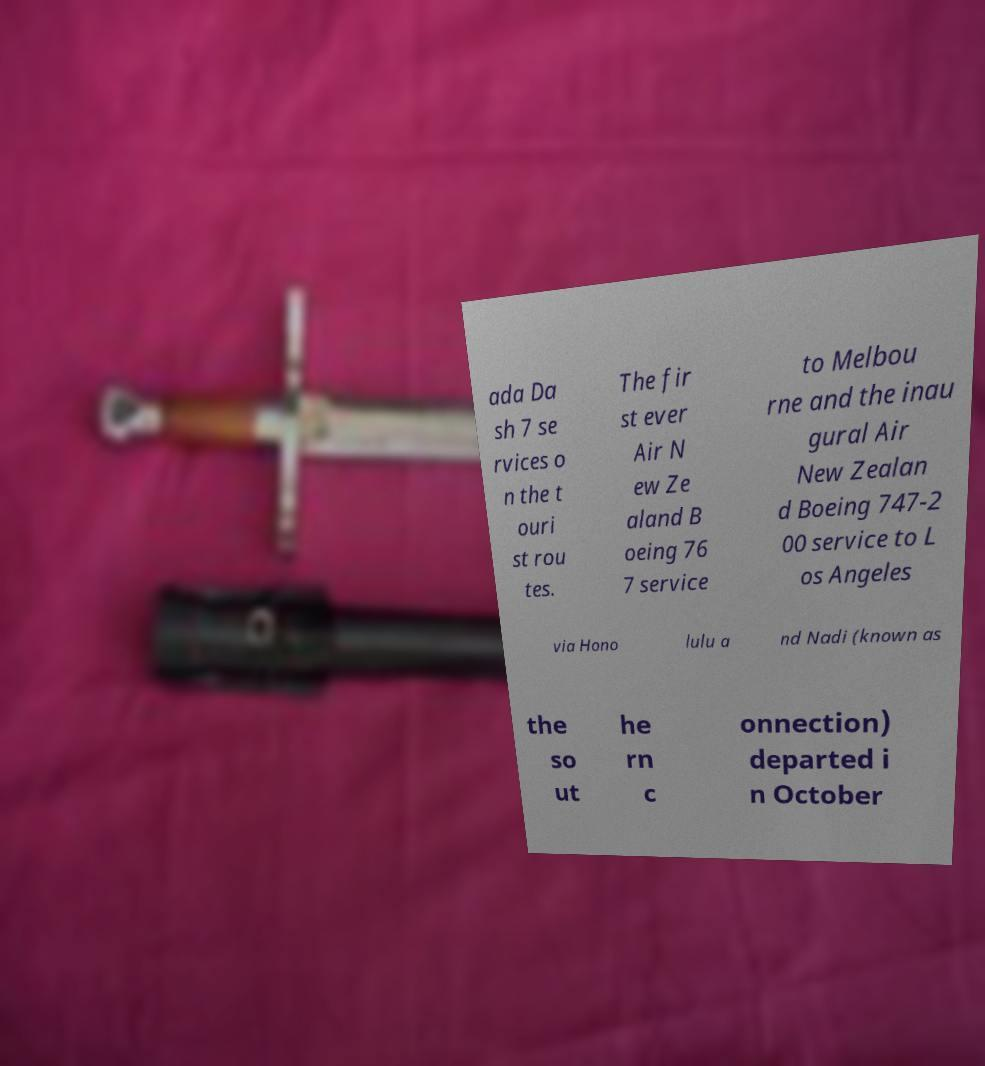For documentation purposes, I need the text within this image transcribed. Could you provide that? ada Da sh 7 se rvices o n the t ouri st rou tes. The fir st ever Air N ew Ze aland B oeing 76 7 service to Melbou rne and the inau gural Air New Zealan d Boeing 747-2 00 service to L os Angeles via Hono lulu a nd Nadi (known as the so ut he rn c onnection) departed i n October 